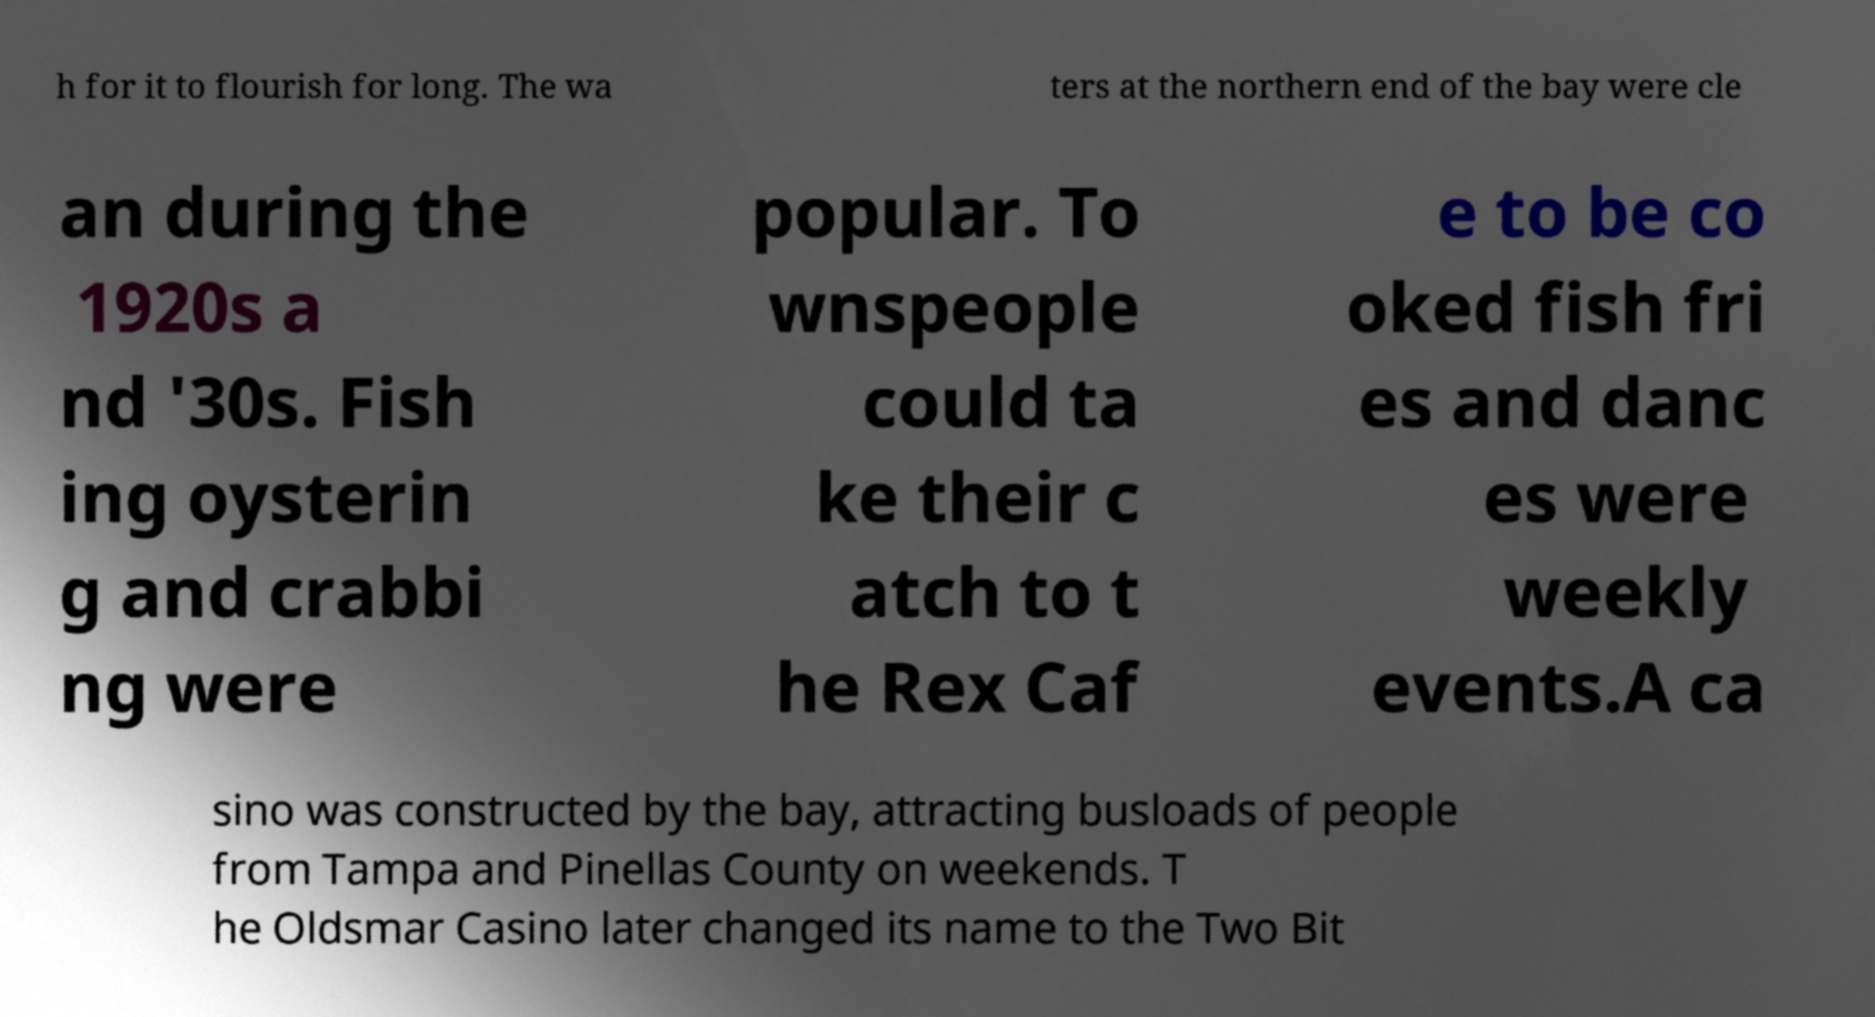Could you assist in decoding the text presented in this image and type it out clearly? h for it to flourish for long. The wa ters at the northern end of the bay were cle an during the 1920s a nd '30s. Fish ing oysterin g and crabbi ng were popular. To wnspeople could ta ke their c atch to t he Rex Caf e to be co oked fish fri es and danc es were weekly events.A ca sino was constructed by the bay, attracting busloads of people from Tampa and Pinellas County on weekends. T he Oldsmar Casino later changed its name to the Two Bit 